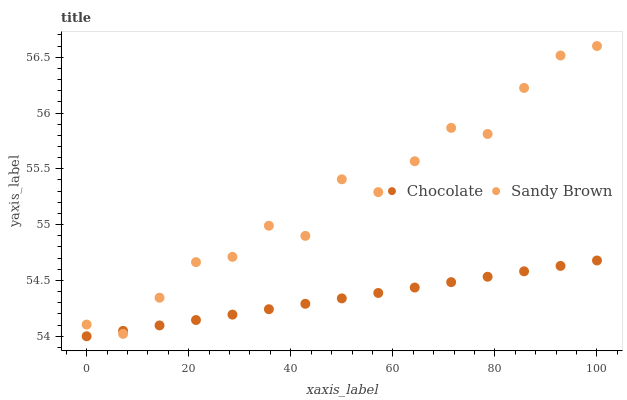Does Chocolate have the minimum area under the curve?
Answer yes or no. Yes. Does Sandy Brown have the maximum area under the curve?
Answer yes or no. Yes. Does Chocolate have the maximum area under the curve?
Answer yes or no. No. Is Chocolate the smoothest?
Answer yes or no. Yes. Is Sandy Brown the roughest?
Answer yes or no. Yes. Is Chocolate the roughest?
Answer yes or no. No. Does Chocolate have the lowest value?
Answer yes or no. Yes. Does Sandy Brown have the highest value?
Answer yes or no. Yes. Does Chocolate have the highest value?
Answer yes or no. No. Does Chocolate intersect Sandy Brown?
Answer yes or no. Yes. Is Chocolate less than Sandy Brown?
Answer yes or no. No. Is Chocolate greater than Sandy Brown?
Answer yes or no. No. 